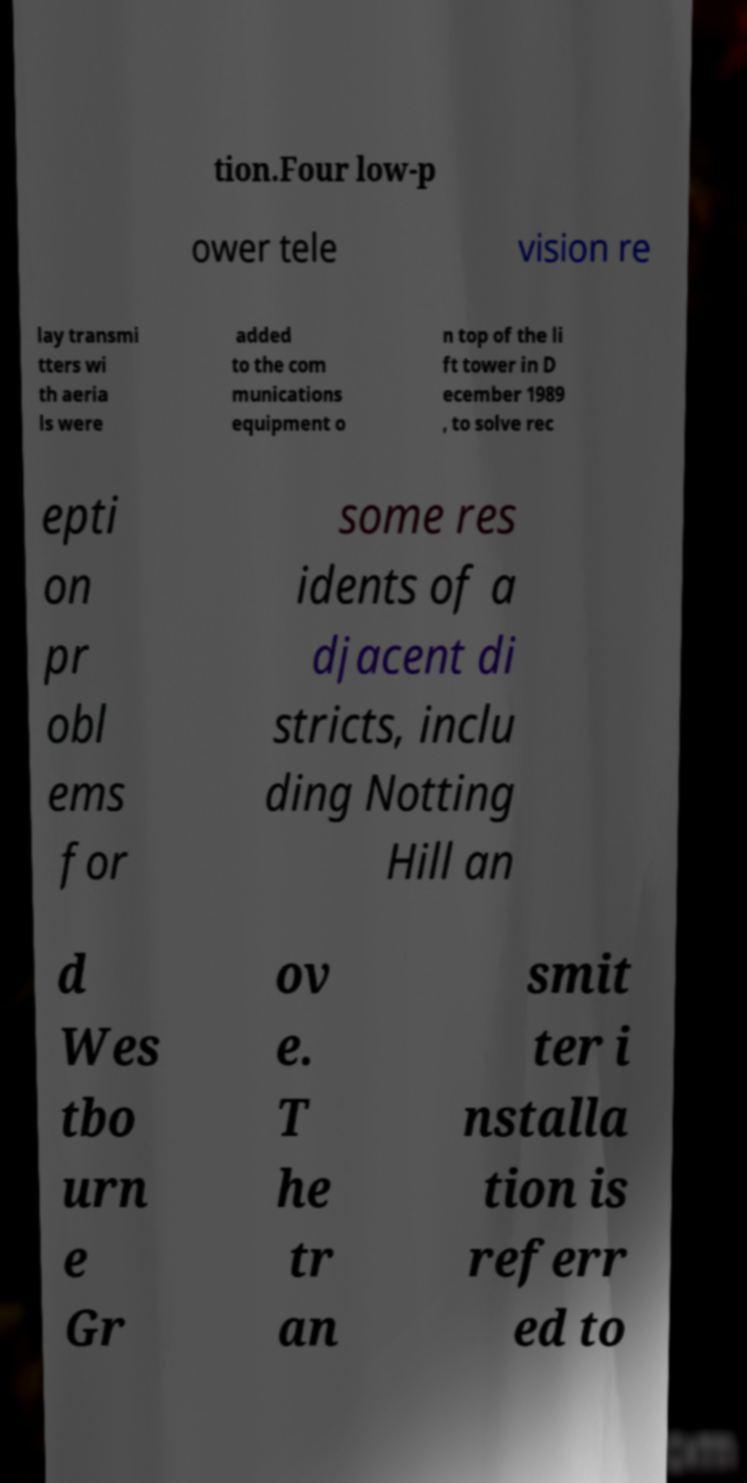What messages or text are displayed in this image? I need them in a readable, typed format. tion.Four low-p ower tele vision re lay transmi tters wi th aeria ls were added to the com munications equipment o n top of the li ft tower in D ecember 1989 , to solve rec epti on pr obl ems for some res idents of a djacent di stricts, inclu ding Notting Hill an d Wes tbo urn e Gr ov e. T he tr an smit ter i nstalla tion is referr ed to 